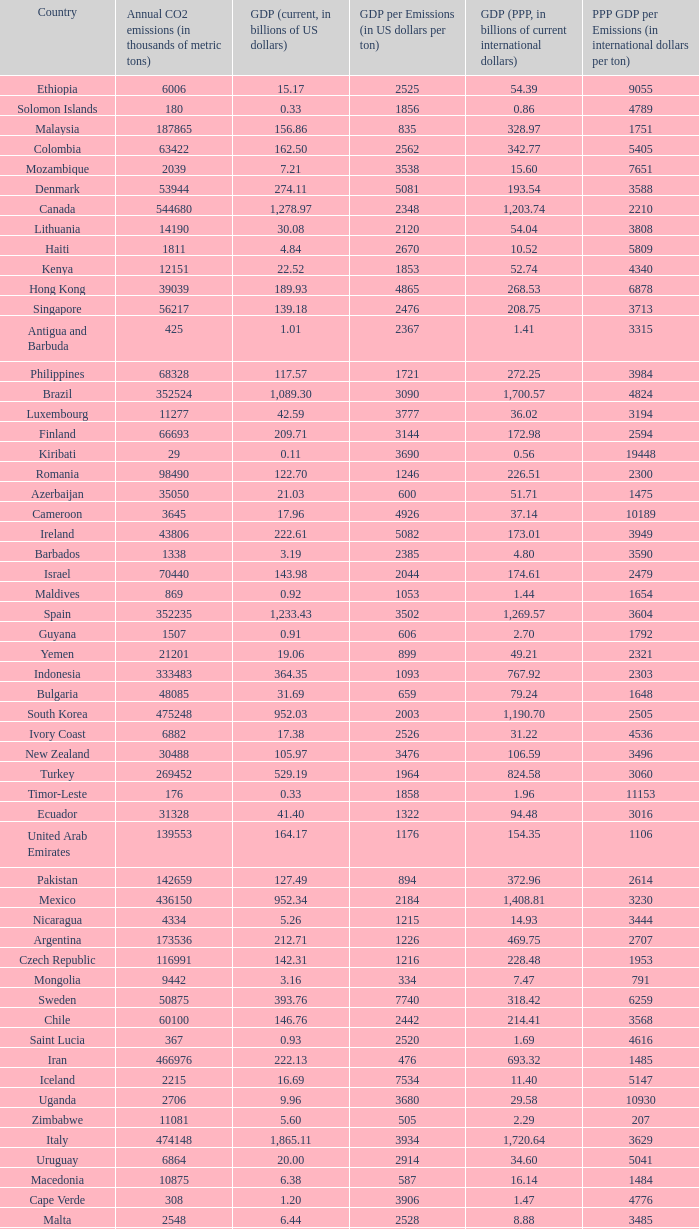When the gdp per emissions (in us dollars per ton) is 3903, what is the maximum annual co2 emissions (in thousands of metric tons)? 935.0. 